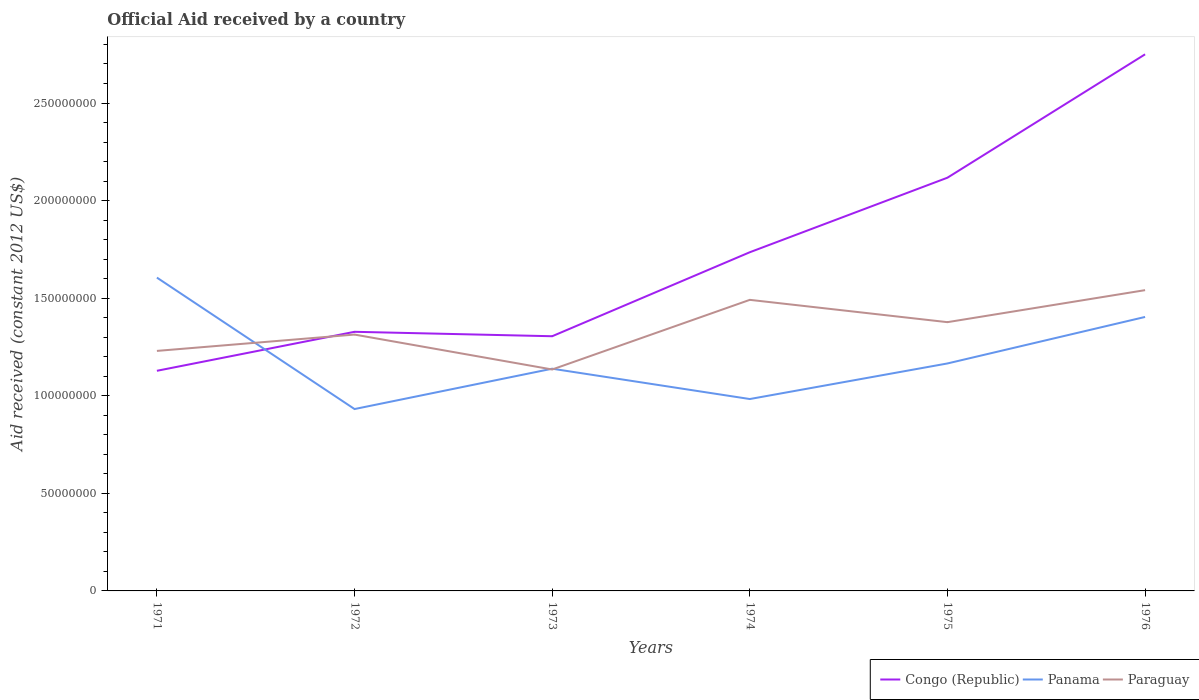How many different coloured lines are there?
Your answer should be compact. 3. Does the line corresponding to Paraguay intersect with the line corresponding to Panama?
Provide a succinct answer. Yes. Is the number of lines equal to the number of legend labels?
Make the answer very short. Yes. Across all years, what is the maximum net official aid received in Panama?
Keep it short and to the point. 9.32e+07. What is the total net official aid received in Panama in the graph?
Keep it short and to the point. -4.72e+07. What is the difference between the highest and the second highest net official aid received in Paraguay?
Your answer should be very brief. 4.06e+07. What is the difference between the highest and the lowest net official aid received in Congo (Republic)?
Your answer should be compact. 3. Is the net official aid received in Paraguay strictly greater than the net official aid received in Congo (Republic) over the years?
Give a very brief answer. No. How many lines are there?
Offer a very short reply. 3. How many years are there in the graph?
Give a very brief answer. 6. Does the graph contain any zero values?
Keep it short and to the point. No. Does the graph contain grids?
Make the answer very short. No. Where does the legend appear in the graph?
Provide a succinct answer. Bottom right. How many legend labels are there?
Make the answer very short. 3. What is the title of the graph?
Ensure brevity in your answer.  Official Aid received by a country. What is the label or title of the X-axis?
Ensure brevity in your answer.  Years. What is the label or title of the Y-axis?
Ensure brevity in your answer.  Aid received (constant 2012 US$). What is the Aid received (constant 2012 US$) of Congo (Republic) in 1971?
Your answer should be compact. 1.13e+08. What is the Aid received (constant 2012 US$) of Panama in 1971?
Offer a terse response. 1.61e+08. What is the Aid received (constant 2012 US$) of Paraguay in 1971?
Give a very brief answer. 1.23e+08. What is the Aid received (constant 2012 US$) of Congo (Republic) in 1972?
Provide a succinct answer. 1.33e+08. What is the Aid received (constant 2012 US$) of Panama in 1972?
Provide a short and direct response. 9.32e+07. What is the Aid received (constant 2012 US$) of Paraguay in 1972?
Give a very brief answer. 1.31e+08. What is the Aid received (constant 2012 US$) of Congo (Republic) in 1973?
Give a very brief answer. 1.30e+08. What is the Aid received (constant 2012 US$) of Panama in 1973?
Give a very brief answer. 1.14e+08. What is the Aid received (constant 2012 US$) of Paraguay in 1973?
Your answer should be compact. 1.13e+08. What is the Aid received (constant 2012 US$) in Congo (Republic) in 1974?
Your answer should be compact. 1.74e+08. What is the Aid received (constant 2012 US$) of Panama in 1974?
Keep it short and to the point. 9.83e+07. What is the Aid received (constant 2012 US$) of Paraguay in 1974?
Provide a succinct answer. 1.49e+08. What is the Aid received (constant 2012 US$) of Congo (Republic) in 1975?
Keep it short and to the point. 2.12e+08. What is the Aid received (constant 2012 US$) in Panama in 1975?
Your response must be concise. 1.17e+08. What is the Aid received (constant 2012 US$) of Paraguay in 1975?
Offer a very short reply. 1.38e+08. What is the Aid received (constant 2012 US$) of Congo (Republic) in 1976?
Keep it short and to the point. 2.75e+08. What is the Aid received (constant 2012 US$) in Panama in 1976?
Offer a terse response. 1.40e+08. What is the Aid received (constant 2012 US$) in Paraguay in 1976?
Make the answer very short. 1.54e+08. Across all years, what is the maximum Aid received (constant 2012 US$) of Congo (Republic)?
Your answer should be compact. 2.75e+08. Across all years, what is the maximum Aid received (constant 2012 US$) of Panama?
Make the answer very short. 1.61e+08. Across all years, what is the maximum Aid received (constant 2012 US$) of Paraguay?
Ensure brevity in your answer.  1.54e+08. Across all years, what is the minimum Aid received (constant 2012 US$) in Congo (Republic)?
Your answer should be compact. 1.13e+08. Across all years, what is the minimum Aid received (constant 2012 US$) in Panama?
Ensure brevity in your answer.  9.32e+07. Across all years, what is the minimum Aid received (constant 2012 US$) in Paraguay?
Offer a terse response. 1.13e+08. What is the total Aid received (constant 2012 US$) of Congo (Republic) in the graph?
Offer a terse response. 1.04e+09. What is the total Aid received (constant 2012 US$) in Panama in the graph?
Your answer should be compact. 7.23e+08. What is the total Aid received (constant 2012 US$) of Paraguay in the graph?
Offer a terse response. 8.09e+08. What is the difference between the Aid received (constant 2012 US$) in Congo (Republic) in 1971 and that in 1972?
Give a very brief answer. -2.00e+07. What is the difference between the Aid received (constant 2012 US$) in Panama in 1971 and that in 1972?
Your response must be concise. 6.74e+07. What is the difference between the Aid received (constant 2012 US$) in Paraguay in 1971 and that in 1972?
Offer a terse response. -8.37e+06. What is the difference between the Aid received (constant 2012 US$) in Congo (Republic) in 1971 and that in 1973?
Your answer should be very brief. -1.77e+07. What is the difference between the Aid received (constant 2012 US$) of Panama in 1971 and that in 1973?
Offer a very short reply. 4.67e+07. What is the difference between the Aid received (constant 2012 US$) of Paraguay in 1971 and that in 1973?
Ensure brevity in your answer.  9.52e+06. What is the difference between the Aid received (constant 2012 US$) in Congo (Republic) in 1971 and that in 1974?
Keep it short and to the point. -6.08e+07. What is the difference between the Aid received (constant 2012 US$) of Panama in 1971 and that in 1974?
Your answer should be compact. 6.22e+07. What is the difference between the Aid received (constant 2012 US$) in Paraguay in 1971 and that in 1974?
Offer a very short reply. -2.62e+07. What is the difference between the Aid received (constant 2012 US$) of Congo (Republic) in 1971 and that in 1975?
Make the answer very short. -9.89e+07. What is the difference between the Aid received (constant 2012 US$) in Panama in 1971 and that in 1975?
Your response must be concise. 4.40e+07. What is the difference between the Aid received (constant 2012 US$) of Paraguay in 1971 and that in 1975?
Offer a terse response. -1.47e+07. What is the difference between the Aid received (constant 2012 US$) in Congo (Republic) in 1971 and that in 1976?
Ensure brevity in your answer.  -1.62e+08. What is the difference between the Aid received (constant 2012 US$) in Panama in 1971 and that in 1976?
Provide a short and direct response. 2.02e+07. What is the difference between the Aid received (constant 2012 US$) of Paraguay in 1971 and that in 1976?
Keep it short and to the point. -3.11e+07. What is the difference between the Aid received (constant 2012 US$) in Congo (Republic) in 1972 and that in 1973?
Your response must be concise. 2.27e+06. What is the difference between the Aid received (constant 2012 US$) of Panama in 1972 and that in 1973?
Your response must be concise. -2.07e+07. What is the difference between the Aid received (constant 2012 US$) of Paraguay in 1972 and that in 1973?
Offer a very short reply. 1.79e+07. What is the difference between the Aid received (constant 2012 US$) of Congo (Republic) in 1972 and that in 1974?
Provide a short and direct response. -4.08e+07. What is the difference between the Aid received (constant 2012 US$) of Panama in 1972 and that in 1974?
Offer a very short reply. -5.13e+06. What is the difference between the Aid received (constant 2012 US$) of Paraguay in 1972 and that in 1974?
Your response must be concise. -1.78e+07. What is the difference between the Aid received (constant 2012 US$) of Congo (Republic) in 1972 and that in 1975?
Offer a very short reply. -7.90e+07. What is the difference between the Aid received (constant 2012 US$) in Panama in 1972 and that in 1975?
Your response must be concise. -2.34e+07. What is the difference between the Aid received (constant 2012 US$) in Paraguay in 1972 and that in 1975?
Provide a succinct answer. -6.36e+06. What is the difference between the Aid received (constant 2012 US$) in Congo (Republic) in 1972 and that in 1976?
Give a very brief answer. -1.42e+08. What is the difference between the Aid received (constant 2012 US$) in Panama in 1972 and that in 1976?
Make the answer very short. -4.72e+07. What is the difference between the Aid received (constant 2012 US$) of Paraguay in 1972 and that in 1976?
Your answer should be compact. -2.28e+07. What is the difference between the Aid received (constant 2012 US$) in Congo (Republic) in 1973 and that in 1974?
Your response must be concise. -4.30e+07. What is the difference between the Aid received (constant 2012 US$) in Panama in 1973 and that in 1974?
Keep it short and to the point. 1.55e+07. What is the difference between the Aid received (constant 2012 US$) of Paraguay in 1973 and that in 1974?
Offer a terse response. -3.57e+07. What is the difference between the Aid received (constant 2012 US$) of Congo (Republic) in 1973 and that in 1975?
Provide a short and direct response. -8.12e+07. What is the difference between the Aid received (constant 2012 US$) of Panama in 1973 and that in 1975?
Provide a short and direct response. -2.69e+06. What is the difference between the Aid received (constant 2012 US$) in Paraguay in 1973 and that in 1975?
Offer a very short reply. -2.42e+07. What is the difference between the Aid received (constant 2012 US$) of Congo (Republic) in 1973 and that in 1976?
Offer a very short reply. -1.44e+08. What is the difference between the Aid received (constant 2012 US$) of Panama in 1973 and that in 1976?
Your answer should be compact. -2.65e+07. What is the difference between the Aid received (constant 2012 US$) of Paraguay in 1973 and that in 1976?
Offer a very short reply. -4.06e+07. What is the difference between the Aid received (constant 2012 US$) in Congo (Republic) in 1974 and that in 1975?
Your answer should be very brief. -3.82e+07. What is the difference between the Aid received (constant 2012 US$) of Panama in 1974 and that in 1975?
Make the answer very short. -1.82e+07. What is the difference between the Aid received (constant 2012 US$) of Paraguay in 1974 and that in 1975?
Your answer should be very brief. 1.14e+07. What is the difference between the Aid received (constant 2012 US$) in Congo (Republic) in 1974 and that in 1976?
Provide a succinct answer. -1.01e+08. What is the difference between the Aid received (constant 2012 US$) in Panama in 1974 and that in 1976?
Give a very brief answer. -4.21e+07. What is the difference between the Aid received (constant 2012 US$) in Paraguay in 1974 and that in 1976?
Make the answer very short. -4.97e+06. What is the difference between the Aid received (constant 2012 US$) of Congo (Republic) in 1975 and that in 1976?
Your response must be concise. -6.32e+07. What is the difference between the Aid received (constant 2012 US$) in Panama in 1975 and that in 1976?
Offer a very short reply. -2.38e+07. What is the difference between the Aid received (constant 2012 US$) of Paraguay in 1975 and that in 1976?
Your answer should be very brief. -1.64e+07. What is the difference between the Aid received (constant 2012 US$) in Congo (Republic) in 1971 and the Aid received (constant 2012 US$) in Panama in 1972?
Ensure brevity in your answer.  1.96e+07. What is the difference between the Aid received (constant 2012 US$) in Congo (Republic) in 1971 and the Aid received (constant 2012 US$) in Paraguay in 1972?
Your answer should be compact. -1.86e+07. What is the difference between the Aid received (constant 2012 US$) of Panama in 1971 and the Aid received (constant 2012 US$) of Paraguay in 1972?
Offer a very short reply. 2.92e+07. What is the difference between the Aid received (constant 2012 US$) of Congo (Republic) in 1971 and the Aid received (constant 2012 US$) of Panama in 1973?
Keep it short and to the point. -1.07e+06. What is the difference between the Aid received (constant 2012 US$) in Congo (Republic) in 1971 and the Aid received (constant 2012 US$) in Paraguay in 1973?
Keep it short and to the point. -6.70e+05. What is the difference between the Aid received (constant 2012 US$) in Panama in 1971 and the Aid received (constant 2012 US$) in Paraguay in 1973?
Your answer should be compact. 4.71e+07. What is the difference between the Aid received (constant 2012 US$) of Congo (Republic) in 1971 and the Aid received (constant 2012 US$) of Panama in 1974?
Offer a terse response. 1.45e+07. What is the difference between the Aid received (constant 2012 US$) in Congo (Republic) in 1971 and the Aid received (constant 2012 US$) in Paraguay in 1974?
Give a very brief answer. -3.64e+07. What is the difference between the Aid received (constant 2012 US$) in Panama in 1971 and the Aid received (constant 2012 US$) in Paraguay in 1974?
Make the answer very short. 1.14e+07. What is the difference between the Aid received (constant 2012 US$) in Congo (Republic) in 1971 and the Aid received (constant 2012 US$) in Panama in 1975?
Your answer should be very brief. -3.76e+06. What is the difference between the Aid received (constant 2012 US$) of Congo (Republic) in 1971 and the Aid received (constant 2012 US$) of Paraguay in 1975?
Give a very brief answer. -2.49e+07. What is the difference between the Aid received (constant 2012 US$) in Panama in 1971 and the Aid received (constant 2012 US$) in Paraguay in 1975?
Keep it short and to the point. 2.28e+07. What is the difference between the Aid received (constant 2012 US$) of Congo (Republic) in 1971 and the Aid received (constant 2012 US$) of Panama in 1976?
Your response must be concise. -2.76e+07. What is the difference between the Aid received (constant 2012 US$) in Congo (Republic) in 1971 and the Aid received (constant 2012 US$) in Paraguay in 1976?
Make the answer very short. -4.13e+07. What is the difference between the Aid received (constant 2012 US$) of Panama in 1971 and the Aid received (constant 2012 US$) of Paraguay in 1976?
Make the answer very short. 6.43e+06. What is the difference between the Aid received (constant 2012 US$) of Congo (Republic) in 1972 and the Aid received (constant 2012 US$) of Panama in 1973?
Keep it short and to the point. 1.89e+07. What is the difference between the Aid received (constant 2012 US$) of Congo (Republic) in 1972 and the Aid received (constant 2012 US$) of Paraguay in 1973?
Give a very brief answer. 1.93e+07. What is the difference between the Aid received (constant 2012 US$) in Panama in 1972 and the Aid received (constant 2012 US$) in Paraguay in 1973?
Give a very brief answer. -2.03e+07. What is the difference between the Aid received (constant 2012 US$) of Congo (Republic) in 1972 and the Aid received (constant 2012 US$) of Panama in 1974?
Your answer should be very brief. 3.44e+07. What is the difference between the Aid received (constant 2012 US$) in Congo (Republic) in 1972 and the Aid received (constant 2012 US$) in Paraguay in 1974?
Your answer should be very brief. -1.64e+07. What is the difference between the Aid received (constant 2012 US$) in Panama in 1972 and the Aid received (constant 2012 US$) in Paraguay in 1974?
Make the answer very short. -5.60e+07. What is the difference between the Aid received (constant 2012 US$) of Congo (Republic) in 1972 and the Aid received (constant 2012 US$) of Panama in 1975?
Offer a terse response. 1.62e+07. What is the difference between the Aid received (constant 2012 US$) of Congo (Republic) in 1972 and the Aid received (constant 2012 US$) of Paraguay in 1975?
Make the answer very short. -4.94e+06. What is the difference between the Aid received (constant 2012 US$) of Panama in 1972 and the Aid received (constant 2012 US$) of Paraguay in 1975?
Give a very brief answer. -4.45e+07. What is the difference between the Aid received (constant 2012 US$) of Congo (Republic) in 1972 and the Aid received (constant 2012 US$) of Panama in 1976?
Keep it short and to the point. -7.61e+06. What is the difference between the Aid received (constant 2012 US$) in Congo (Republic) in 1972 and the Aid received (constant 2012 US$) in Paraguay in 1976?
Offer a very short reply. -2.13e+07. What is the difference between the Aid received (constant 2012 US$) in Panama in 1972 and the Aid received (constant 2012 US$) in Paraguay in 1976?
Your answer should be compact. -6.09e+07. What is the difference between the Aid received (constant 2012 US$) of Congo (Republic) in 1973 and the Aid received (constant 2012 US$) of Panama in 1974?
Your response must be concise. 3.22e+07. What is the difference between the Aid received (constant 2012 US$) in Congo (Republic) in 1973 and the Aid received (constant 2012 US$) in Paraguay in 1974?
Your answer should be very brief. -1.86e+07. What is the difference between the Aid received (constant 2012 US$) in Panama in 1973 and the Aid received (constant 2012 US$) in Paraguay in 1974?
Offer a very short reply. -3.53e+07. What is the difference between the Aid received (constant 2012 US$) of Congo (Republic) in 1973 and the Aid received (constant 2012 US$) of Panama in 1975?
Offer a terse response. 1.40e+07. What is the difference between the Aid received (constant 2012 US$) in Congo (Republic) in 1973 and the Aid received (constant 2012 US$) in Paraguay in 1975?
Your answer should be compact. -7.21e+06. What is the difference between the Aid received (constant 2012 US$) in Panama in 1973 and the Aid received (constant 2012 US$) in Paraguay in 1975?
Your response must be concise. -2.38e+07. What is the difference between the Aid received (constant 2012 US$) in Congo (Republic) in 1973 and the Aid received (constant 2012 US$) in Panama in 1976?
Your response must be concise. -9.88e+06. What is the difference between the Aid received (constant 2012 US$) in Congo (Republic) in 1973 and the Aid received (constant 2012 US$) in Paraguay in 1976?
Provide a short and direct response. -2.36e+07. What is the difference between the Aid received (constant 2012 US$) in Panama in 1973 and the Aid received (constant 2012 US$) in Paraguay in 1976?
Your answer should be compact. -4.02e+07. What is the difference between the Aid received (constant 2012 US$) of Congo (Republic) in 1974 and the Aid received (constant 2012 US$) of Panama in 1975?
Ensure brevity in your answer.  5.70e+07. What is the difference between the Aid received (constant 2012 US$) in Congo (Republic) in 1974 and the Aid received (constant 2012 US$) in Paraguay in 1975?
Ensure brevity in your answer.  3.58e+07. What is the difference between the Aid received (constant 2012 US$) in Panama in 1974 and the Aid received (constant 2012 US$) in Paraguay in 1975?
Provide a succinct answer. -3.94e+07. What is the difference between the Aid received (constant 2012 US$) of Congo (Republic) in 1974 and the Aid received (constant 2012 US$) of Panama in 1976?
Make the answer very short. 3.32e+07. What is the difference between the Aid received (constant 2012 US$) in Congo (Republic) in 1974 and the Aid received (constant 2012 US$) in Paraguay in 1976?
Offer a very short reply. 1.94e+07. What is the difference between the Aid received (constant 2012 US$) of Panama in 1974 and the Aid received (constant 2012 US$) of Paraguay in 1976?
Keep it short and to the point. -5.58e+07. What is the difference between the Aid received (constant 2012 US$) of Congo (Republic) in 1975 and the Aid received (constant 2012 US$) of Panama in 1976?
Your answer should be compact. 7.14e+07. What is the difference between the Aid received (constant 2012 US$) of Congo (Republic) in 1975 and the Aid received (constant 2012 US$) of Paraguay in 1976?
Give a very brief answer. 5.76e+07. What is the difference between the Aid received (constant 2012 US$) in Panama in 1975 and the Aid received (constant 2012 US$) in Paraguay in 1976?
Offer a terse response. -3.76e+07. What is the average Aid received (constant 2012 US$) in Congo (Republic) per year?
Your answer should be compact. 1.73e+08. What is the average Aid received (constant 2012 US$) in Panama per year?
Offer a terse response. 1.20e+08. What is the average Aid received (constant 2012 US$) in Paraguay per year?
Offer a terse response. 1.35e+08. In the year 1971, what is the difference between the Aid received (constant 2012 US$) in Congo (Republic) and Aid received (constant 2012 US$) in Panama?
Your answer should be compact. -4.78e+07. In the year 1971, what is the difference between the Aid received (constant 2012 US$) in Congo (Republic) and Aid received (constant 2012 US$) in Paraguay?
Make the answer very short. -1.02e+07. In the year 1971, what is the difference between the Aid received (constant 2012 US$) of Panama and Aid received (constant 2012 US$) of Paraguay?
Offer a terse response. 3.76e+07. In the year 1972, what is the difference between the Aid received (constant 2012 US$) of Congo (Republic) and Aid received (constant 2012 US$) of Panama?
Your answer should be compact. 3.96e+07. In the year 1972, what is the difference between the Aid received (constant 2012 US$) in Congo (Republic) and Aid received (constant 2012 US$) in Paraguay?
Provide a short and direct response. 1.42e+06. In the year 1972, what is the difference between the Aid received (constant 2012 US$) in Panama and Aid received (constant 2012 US$) in Paraguay?
Your answer should be very brief. -3.82e+07. In the year 1973, what is the difference between the Aid received (constant 2012 US$) of Congo (Republic) and Aid received (constant 2012 US$) of Panama?
Offer a very short reply. 1.66e+07. In the year 1973, what is the difference between the Aid received (constant 2012 US$) in Congo (Republic) and Aid received (constant 2012 US$) in Paraguay?
Provide a short and direct response. 1.70e+07. In the year 1973, what is the difference between the Aid received (constant 2012 US$) of Panama and Aid received (constant 2012 US$) of Paraguay?
Provide a short and direct response. 4.00e+05. In the year 1974, what is the difference between the Aid received (constant 2012 US$) of Congo (Republic) and Aid received (constant 2012 US$) of Panama?
Your answer should be compact. 7.52e+07. In the year 1974, what is the difference between the Aid received (constant 2012 US$) in Congo (Republic) and Aid received (constant 2012 US$) in Paraguay?
Your answer should be compact. 2.44e+07. In the year 1974, what is the difference between the Aid received (constant 2012 US$) of Panama and Aid received (constant 2012 US$) of Paraguay?
Ensure brevity in your answer.  -5.08e+07. In the year 1975, what is the difference between the Aid received (constant 2012 US$) in Congo (Republic) and Aid received (constant 2012 US$) in Panama?
Your answer should be very brief. 9.52e+07. In the year 1975, what is the difference between the Aid received (constant 2012 US$) in Congo (Republic) and Aid received (constant 2012 US$) in Paraguay?
Offer a terse response. 7.40e+07. In the year 1975, what is the difference between the Aid received (constant 2012 US$) of Panama and Aid received (constant 2012 US$) of Paraguay?
Provide a short and direct response. -2.12e+07. In the year 1976, what is the difference between the Aid received (constant 2012 US$) in Congo (Republic) and Aid received (constant 2012 US$) in Panama?
Offer a terse response. 1.35e+08. In the year 1976, what is the difference between the Aid received (constant 2012 US$) of Congo (Republic) and Aid received (constant 2012 US$) of Paraguay?
Your answer should be compact. 1.21e+08. In the year 1976, what is the difference between the Aid received (constant 2012 US$) in Panama and Aid received (constant 2012 US$) in Paraguay?
Your answer should be very brief. -1.37e+07. What is the ratio of the Aid received (constant 2012 US$) in Congo (Republic) in 1971 to that in 1972?
Offer a very short reply. 0.85. What is the ratio of the Aid received (constant 2012 US$) of Panama in 1971 to that in 1972?
Keep it short and to the point. 1.72. What is the ratio of the Aid received (constant 2012 US$) of Paraguay in 1971 to that in 1972?
Your response must be concise. 0.94. What is the ratio of the Aid received (constant 2012 US$) in Congo (Republic) in 1971 to that in 1973?
Provide a succinct answer. 0.86. What is the ratio of the Aid received (constant 2012 US$) in Panama in 1971 to that in 1973?
Provide a short and direct response. 1.41. What is the ratio of the Aid received (constant 2012 US$) of Paraguay in 1971 to that in 1973?
Offer a very short reply. 1.08. What is the ratio of the Aid received (constant 2012 US$) of Congo (Republic) in 1971 to that in 1974?
Offer a very short reply. 0.65. What is the ratio of the Aid received (constant 2012 US$) of Panama in 1971 to that in 1974?
Keep it short and to the point. 1.63. What is the ratio of the Aid received (constant 2012 US$) of Paraguay in 1971 to that in 1974?
Keep it short and to the point. 0.82. What is the ratio of the Aid received (constant 2012 US$) in Congo (Republic) in 1971 to that in 1975?
Your answer should be compact. 0.53. What is the ratio of the Aid received (constant 2012 US$) of Panama in 1971 to that in 1975?
Keep it short and to the point. 1.38. What is the ratio of the Aid received (constant 2012 US$) of Paraguay in 1971 to that in 1975?
Offer a terse response. 0.89. What is the ratio of the Aid received (constant 2012 US$) of Congo (Republic) in 1971 to that in 1976?
Offer a terse response. 0.41. What is the ratio of the Aid received (constant 2012 US$) in Panama in 1971 to that in 1976?
Offer a terse response. 1.14. What is the ratio of the Aid received (constant 2012 US$) in Paraguay in 1971 to that in 1976?
Give a very brief answer. 0.8. What is the ratio of the Aid received (constant 2012 US$) in Congo (Republic) in 1972 to that in 1973?
Keep it short and to the point. 1.02. What is the ratio of the Aid received (constant 2012 US$) in Panama in 1972 to that in 1973?
Ensure brevity in your answer.  0.82. What is the ratio of the Aid received (constant 2012 US$) in Paraguay in 1972 to that in 1973?
Provide a short and direct response. 1.16. What is the ratio of the Aid received (constant 2012 US$) in Congo (Republic) in 1972 to that in 1974?
Offer a terse response. 0.77. What is the ratio of the Aid received (constant 2012 US$) in Panama in 1972 to that in 1974?
Your answer should be very brief. 0.95. What is the ratio of the Aid received (constant 2012 US$) in Paraguay in 1972 to that in 1974?
Make the answer very short. 0.88. What is the ratio of the Aid received (constant 2012 US$) of Congo (Republic) in 1972 to that in 1975?
Give a very brief answer. 0.63. What is the ratio of the Aid received (constant 2012 US$) in Panama in 1972 to that in 1975?
Provide a succinct answer. 0.8. What is the ratio of the Aid received (constant 2012 US$) in Paraguay in 1972 to that in 1975?
Give a very brief answer. 0.95. What is the ratio of the Aid received (constant 2012 US$) of Congo (Republic) in 1972 to that in 1976?
Offer a terse response. 0.48. What is the ratio of the Aid received (constant 2012 US$) of Panama in 1972 to that in 1976?
Keep it short and to the point. 0.66. What is the ratio of the Aid received (constant 2012 US$) in Paraguay in 1972 to that in 1976?
Provide a short and direct response. 0.85. What is the ratio of the Aid received (constant 2012 US$) in Congo (Republic) in 1973 to that in 1974?
Offer a very short reply. 0.75. What is the ratio of the Aid received (constant 2012 US$) in Panama in 1973 to that in 1974?
Provide a short and direct response. 1.16. What is the ratio of the Aid received (constant 2012 US$) in Paraguay in 1973 to that in 1974?
Provide a succinct answer. 0.76. What is the ratio of the Aid received (constant 2012 US$) in Congo (Republic) in 1973 to that in 1975?
Your response must be concise. 0.62. What is the ratio of the Aid received (constant 2012 US$) in Panama in 1973 to that in 1975?
Your answer should be compact. 0.98. What is the ratio of the Aid received (constant 2012 US$) of Paraguay in 1973 to that in 1975?
Keep it short and to the point. 0.82. What is the ratio of the Aid received (constant 2012 US$) in Congo (Republic) in 1973 to that in 1976?
Give a very brief answer. 0.47. What is the ratio of the Aid received (constant 2012 US$) of Panama in 1973 to that in 1976?
Your answer should be very brief. 0.81. What is the ratio of the Aid received (constant 2012 US$) of Paraguay in 1973 to that in 1976?
Give a very brief answer. 0.74. What is the ratio of the Aid received (constant 2012 US$) in Congo (Republic) in 1974 to that in 1975?
Give a very brief answer. 0.82. What is the ratio of the Aid received (constant 2012 US$) of Panama in 1974 to that in 1975?
Your answer should be very brief. 0.84. What is the ratio of the Aid received (constant 2012 US$) in Paraguay in 1974 to that in 1975?
Provide a short and direct response. 1.08. What is the ratio of the Aid received (constant 2012 US$) in Congo (Republic) in 1974 to that in 1976?
Provide a succinct answer. 0.63. What is the ratio of the Aid received (constant 2012 US$) of Panama in 1974 to that in 1976?
Provide a short and direct response. 0.7. What is the ratio of the Aid received (constant 2012 US$) of Paraguay in 1974 to that in 1976?
Offer a very short reply. 0.97. What is the ratio of the Aid received (constant 2012 US$) in Congo (Republic) in 1975 to that in 1976?
Ensure brevity in your answer.  0.77. What is the ratio of the Aid received (constant 2012 US$) of Panama in 1975 to that in 1976?
Make the answer very short. 0.83. What is the ratio of the Aid received (constant 2012 US$) of Paraguay in 1975 to that in 1976?
Your answer should be very brief. 0.89. What is the difference between the highest and the second highest Aid received (constant 2012 US$) of Congo (Republic)?
Offer a very short reply. 6.32e+07. What is the difference between the highest and the second highest Aid received (constant 2012 US$) in Panama?
Offer a very short reply. 2.02e+07. What is the difference between the highest and the second highest Aid received (constant 2012 US$) of Paraguay?
Keep it short and to the point. 4.97e+06. What is the difference between the highest and the lowest Aid received (constant 2012 US$) in Congo (Republic)?
Give a very brief answer. 1.62e+08. What is the difference between the highest and the lowest Aid received (constant 2012 US$) in Panama?
Keep it short and to the point. 6.74e+07. What is the difference between the highest and the lowest Aid received (constant 2012 US$) in Paraguay?
Keep it short and to the point. 4.06e+07. 